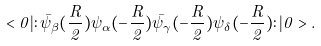Convert formula to latex. <formula><loc_0><loc_0><loc_500><loc_500>< 0 | \colon \bar { \psi } _ { \beta } ( \frac { R } { 2 } ) \psi _ { \alpha } ( - \frac { R } { 2 } ) \bar { \psi } _ { \gamma } ( - \frac { R } { 2 } ) \psi _ { \delta } ( - \frac { R } { 2 } ) \colon | 0 > .</formula> 